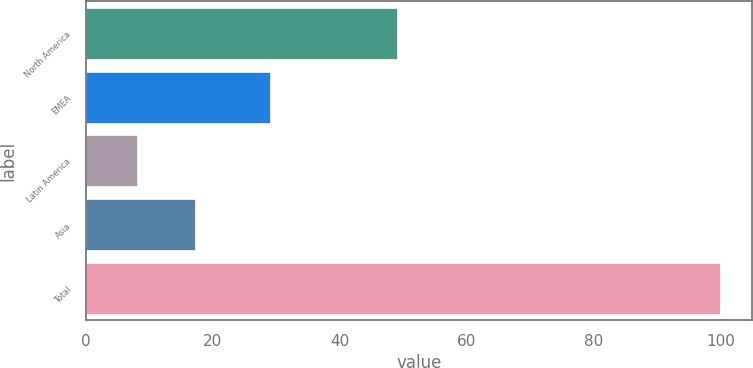Convert chart to OTSL. <chart><loc_0><loc_0><loc_500><loc_500><bar_chart><fcel>North America<fcel>EMEA<fcel>Latin America<fcel>Asia<fcel>Total<nl><fcel>49<fcel>29<fcel>8<fcel>17.2<fcel>100<nl></chart> 